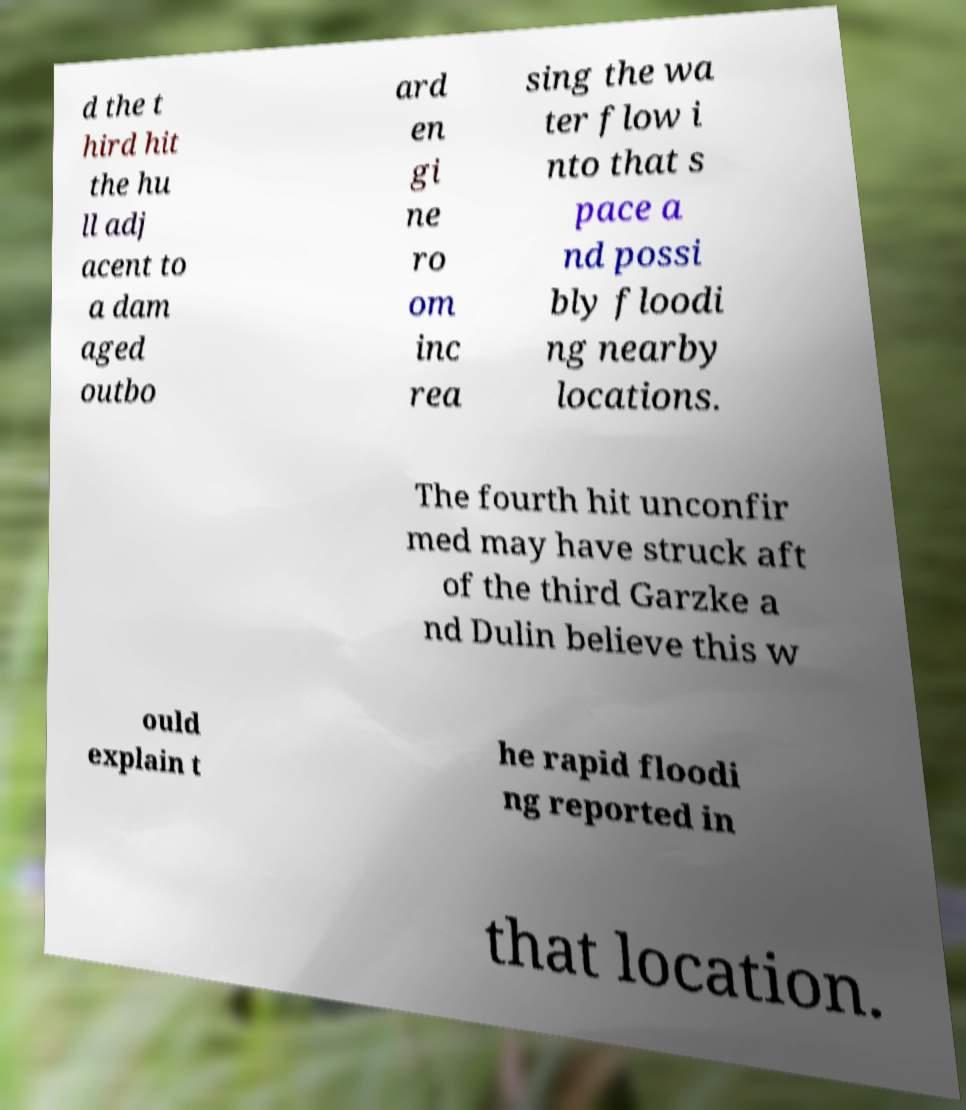For documentation purposes, I need the text within this image transcribed. Could you provide that? d the t hird hit the hu ll adj acent to a dam aged outbo ard en gi ne ro om inc rea sing the wa ter flow i nto that s pace a nd possi bly floodi ng nearby locations. The fourth hit unconfir med may have struck aft of the third Garzke a nd Dulin believe this w ould explain t he rapid floodi ng reported in that location. 